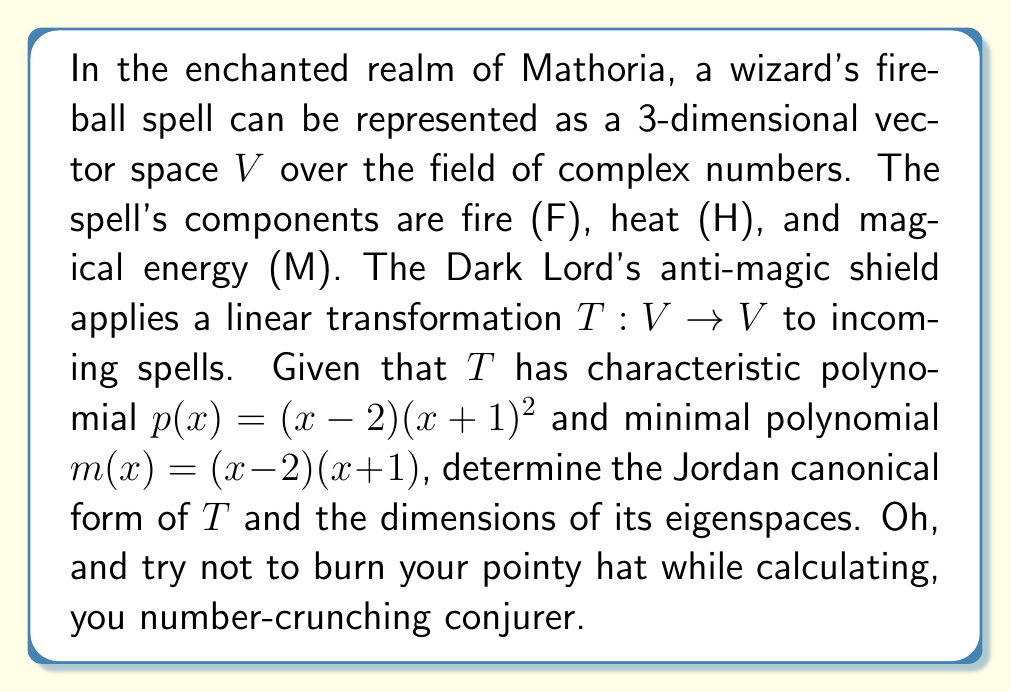Solve this math problem. Let's break this down step by step, you mathmagical smartypants:

1) First, we need to identify the eigenvalues of $T$. These are the roots of the characteristic polynomial $p(x) = (x-2)(x+1)^2$. So, the eigenvalues are:
   $\lambda_1 = 2$ (with algebraic multiplicity 1)
   $\lambda_2 = -1$ (with algebraic multiplicity 2)

2) The minimal polynomial $m(x) = (x-2)(x+1)$ tells us that the geometric multiplicity of $\lambda_2 = -1$ is 1. This means the Jordan block for $\lambda_2$ will be of size 2x2.

3) The Jordan canonical form will therefore be:

   $$J = \begin{pmatrix}
   2 & 0 & 0 \\
   0 & -1 & 1 \\
   0 & 0 & -1
   \end{pmatrix}$$

4) To find the dimensions of the eigenspaces:
   - For $\lambda_1 = 2$: The geometric multiplicity is 1, so $\dim(E_2) = 1$
   - For $\lambda_2 = -1$: The geometric multiplicity is 1, so $\dim(E_{-1}) = 1$

5) The total dimension of the eigenspaces is therefore 2, which is less than the dimension of $V$ (which is 3). This confirms that $T$ is not diagonalizable.

So there you have it, you spell-slinging number wizard. The Jordan form reveals the true nature of the Dark Lord's shield, decomposing it into its irreducible components faster than you can say "Abracadabra!"
Answer: Jordan form: $J = \begin{pmatrix} 2 & 0 & 0 \\ 0 & -1 & 1 \\ 0 & 0 & -1 \end{pmatrix}$; Eigenspace dimensions: $\dim(E_2) = 1$, $\dim(E_{-1}) = 1$ 